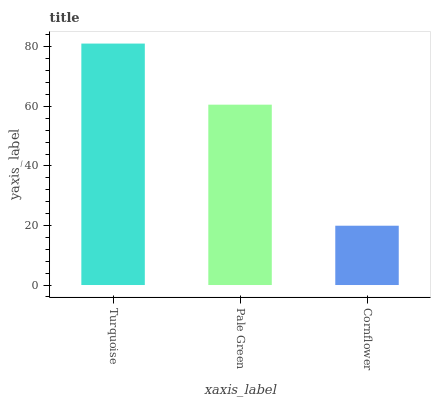Is Cornflower the minimum?
Answer yes or no. Yes. Is Turquoise the maximum?
Answer yes or no. Yes. Is Pale Green the minimum?
Answer yes or no. No. Is Pale Green the maximum?
Answer yes or no. No. Is Turquoise greater than Pale Green?
Answer yes or no. Yes. Is Pale Green less than Turquoise?
Answer yes or no. Yes. Is Pale Green greater than Turquoise?
Answer yes or no. No. Is Turquoise less than Pale Green?
Answer yes or no. No. Is Pale Green the high median?
Answer yes or no. Yes. Is Pale Green the low median?
Answer yes or no. Yes. Is Cornflower the high median?
Answer yes or no. No. Is Cornflower the low median?
Answer yes or no. No. 